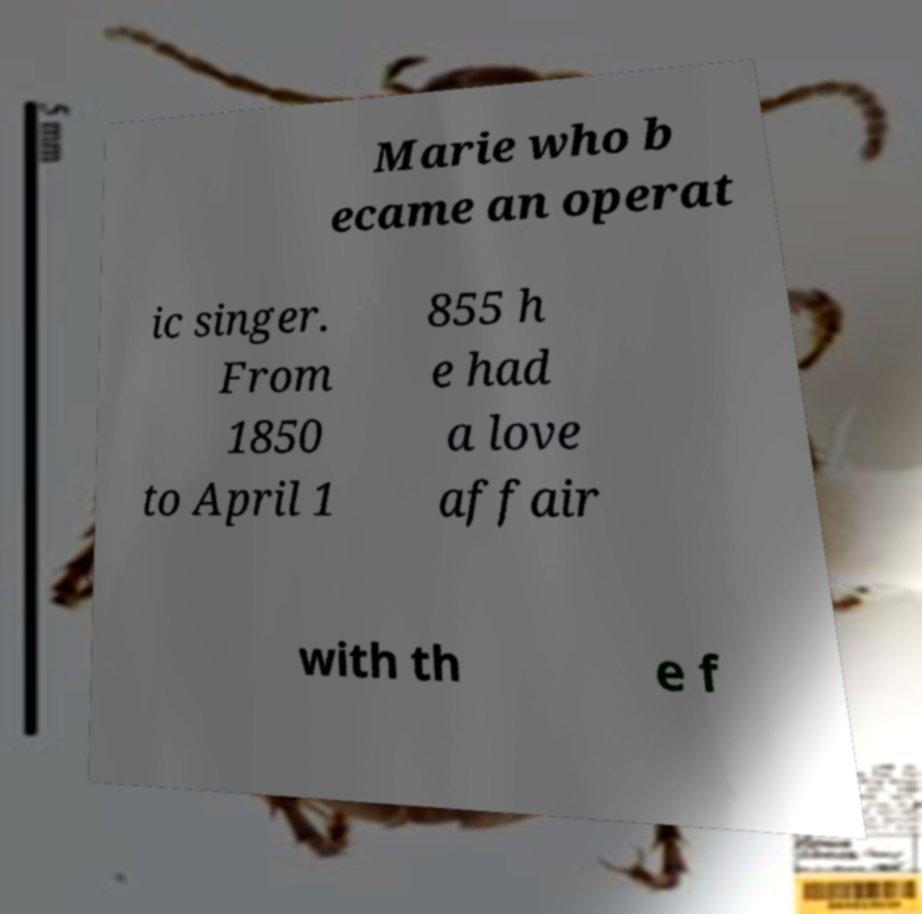Could you extract and type out the text from this image? Marie who b ecame an operat ic singer. From 1850 to April 1 855 h e had a love affair with th e f 